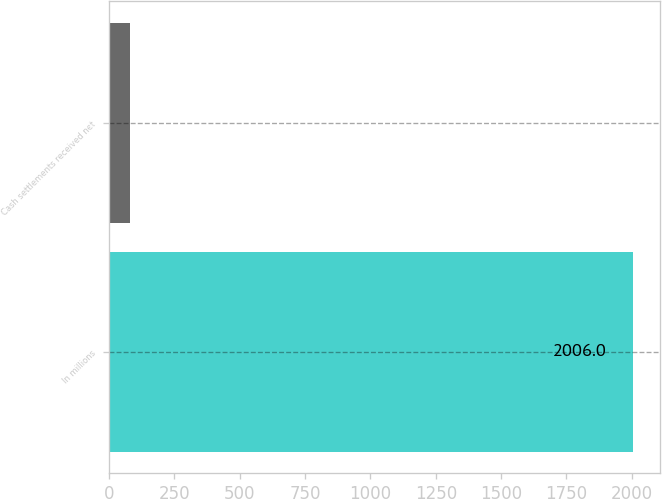<chart> <loc_0><loc_0><loc_500><loc_500><bar_chart><fcel>In millions<fcel>Cash settlements received net<nl><fcel>2006<fcel>80<nl></chart> 